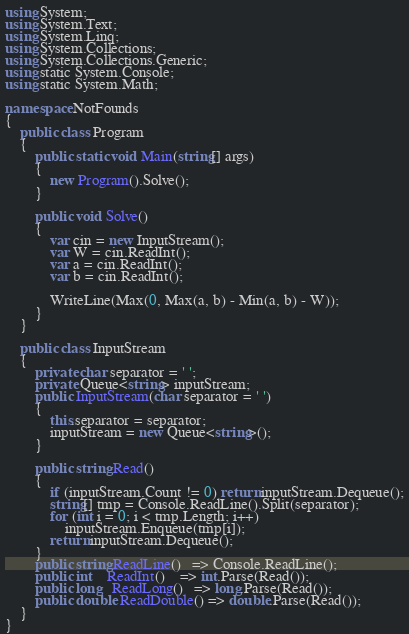Convert code to text. <code><loc_0><loc_0><loc_500><loc_500><_C#_>using System;
using System.Text;
using System.Linq;
using System.Collections;
using System.Collections.Generic;
using static System.Console;
using static System.Math;

namespace NotFounds
{
    public class Program
    {
        public static void Main(string[] args)
        {
            new Program().Solve();
        }

        public void Solve()
        {
            var cin = new InputStream();
            var W = cin.ReadInt();
            var a = cin.ReadInt();
            var b = cin.ReadInt();

            WriteLine(Max(0, Max(a, b) - Min(a, b) - W));
        }
    }

    public class InputStream
    {
        private char separator = ' ';
        private Queue<string> inputStream;
        public InputStream(char separator = ' ')
        {
            this.separator = separator;
            inputStream = new Queue<string>();
        }

        public string Read()
        {
            if (inputStream.Count != 0) return inputStream.Dequeue();
            string[] tmp = Console.ReadLine().Split(separator);
            for (int i = 0; i < tmp.Length; i++)
                inputStream.Enqueue(tmp[i]);
            return inputStream.Dequeue();
        }
        public string ReadLine()   => Console.ReadLine();
        public int    ReadInt()    => int.Parse(Read());
        public long   ReadLong()   => long.Parse(Read());
        public double ReadDouble() => double.Parse(Read());
    }
}</code> 